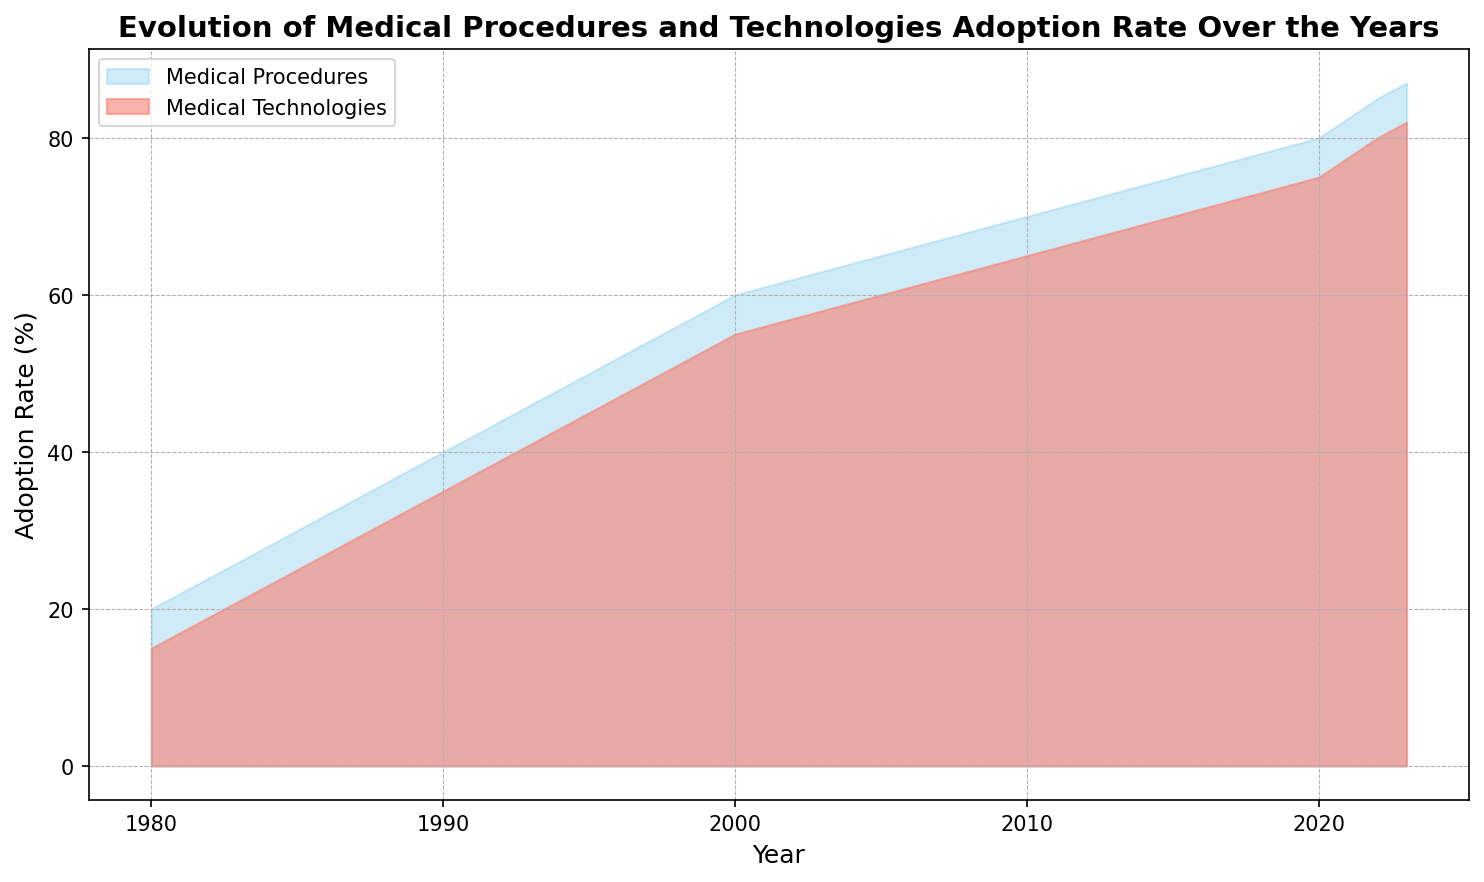What is the adoption rate of medical procedures in 1990? The plot shows the adoption rate of medical procedures over the years. By looking at the chart and locating 1990 on the x-axis, you can see the height of the blue area that corresponds to medical procedures.
Answer: 40% How does the adoption rate of medical technologies in 2023 compare to that in 1985? To answer this, locate the values for the adoption rate of medical technologies in 2023 and 1985. In 2023, the adoption rate is 82%, and in 1985, it is 25%.
Answer: 2023 is greater Between what years did the adoption rate of medical procedures increase the most? To find this, look for the steepest increase in the height of the sky-blue area over the years. The largest increase occurs between 1980 (20%) and 1985 (30%), where the increase was 10%.
Answer: 1980-1985 What is the difference in adoption rates between medical procedures and technologies in 2020? In 2020, the adoption rate for medical procedures is 80% and for medical technologies is 75%. The difference is calculated as 80% - 75% = 5%.
Answer: 5% What trend is observed for both medical procedures and technologies from 2010 to 2023? From the visual attributes, both the sky-blue and salmon areas show an upward trend from 2010 to 2023, indicating an increase in the adoption rates for both medical procedures and technologies during this period.
Answer: Increasing trend By how much did the adoption rate for medical technologies increase from 2000 to 2022? In 2000, the adoption rate was 55%, and in 2022, it was 80%. The increase is 80% - 55% = 25%.
Answer: 25% Which year had the closest adoption rates between medical procedures and medical technologies? By looking at the overlap and closeness of the blue and salmon areas, the year 2005 shows rates of 65% for procedures and 60% for technologies, making the difference only 5%.
Answer: 2005 What is the average adoption rate for medical procedures from 1980 to 2023? To find the average, sum up the adoption rates for each year and divide by the number of years: (20+30+40+50+60+65+70+75+80+85+87)/11 = 61.18%.
Answer: 61.18% Compare the overall growth pattern of medical procedures to medical technologies from 1980 to 2023. Both medical procedures and technologies show a steady increase in adoption rates over the years, but medical procedures consistently have higher adoption rates compared to technologies.
Answer: Procedural growth > Technological growth By what percentage did the adoption rate of medical procedures and medical technologies differ in 1995? In 1995, the adoption rates were 50% for procedures and 45% for technologies. The difference is calculated as 50% - 45% = 5%.
Answer: 5% 